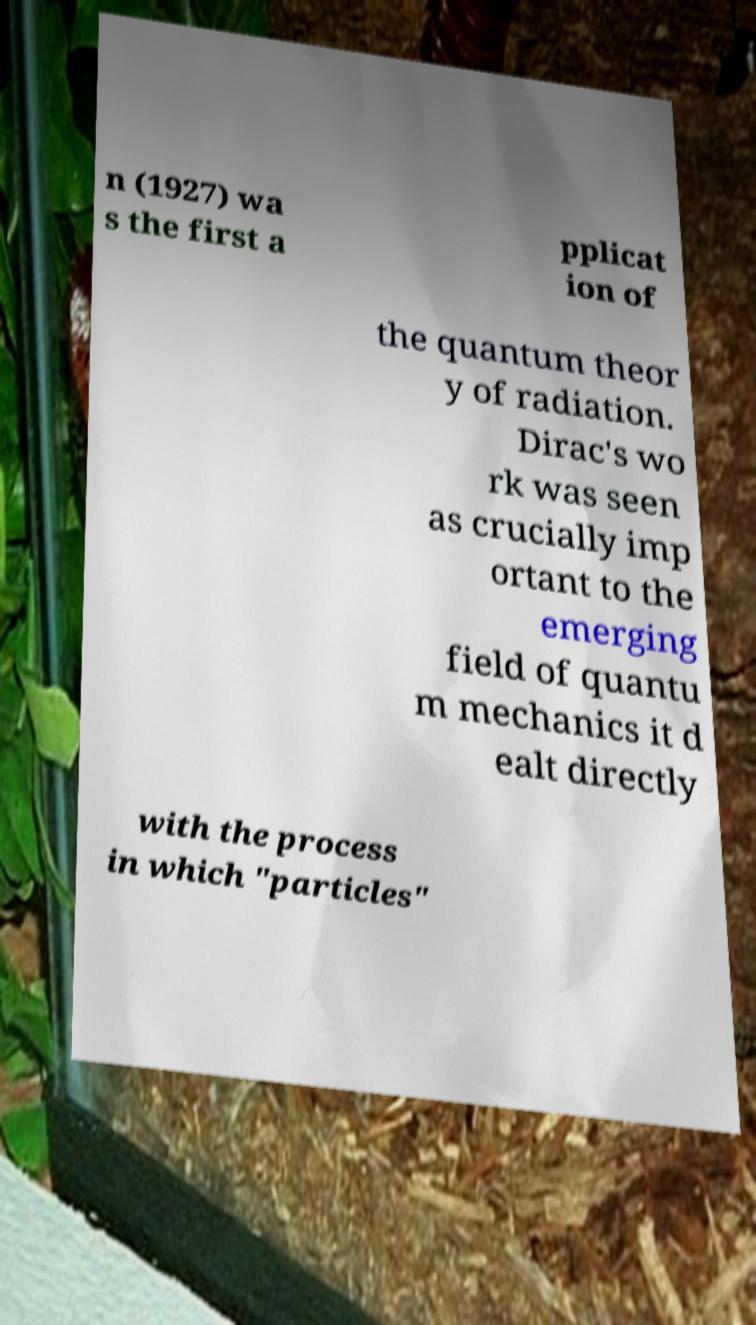Please read and relay the text visible in this image. What does it say? n (1927) wa s the first a pplicat ion of the quantum theor y of radiation. Dirac's wo rk was seen as crucially imp ortant to the emerging field of quantu m mechanics it d ealt directly with the process in which "particles" 